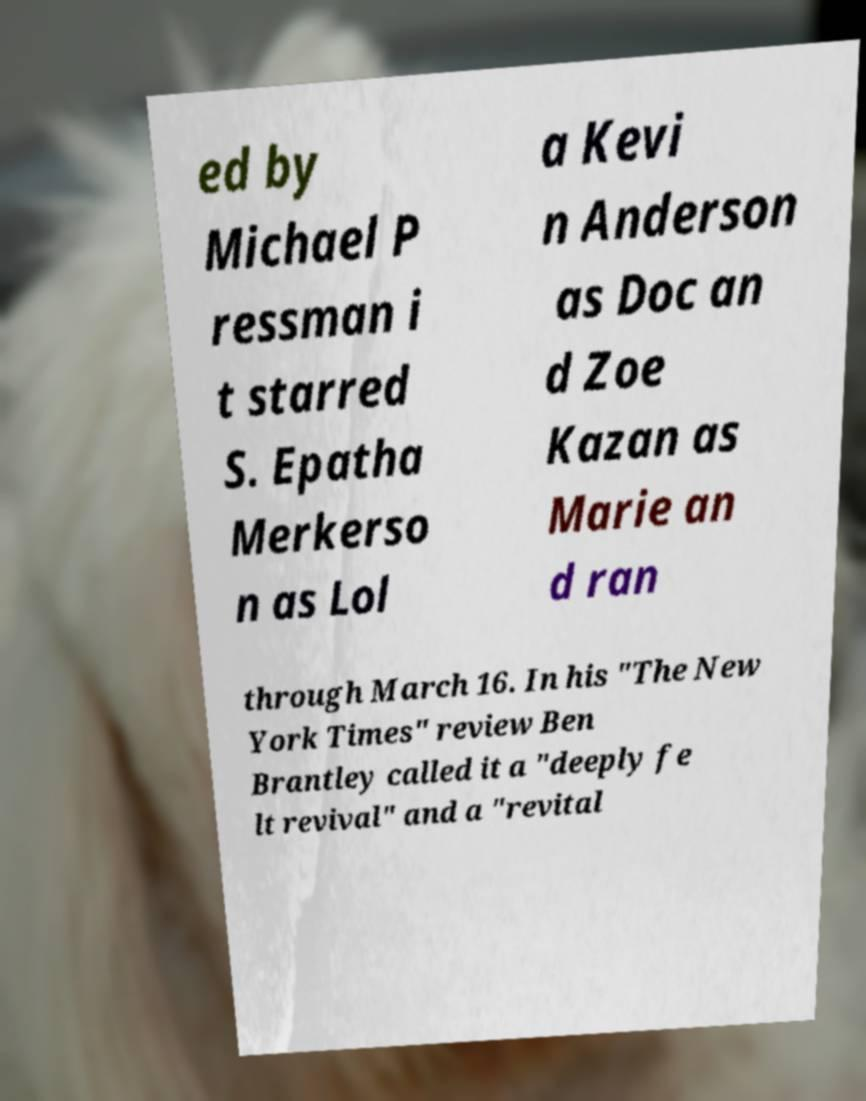Could you assist in decoding the text presented in this image and type it out clearly? ed by Michael P ressman i t starred S. Epatha Merkerso n as Lol a Kevi n Anderson as Doc an d Zoe Kazan as Marie an d ran through March 16. In his "The New York Times" review Ben Brantley called it a "deeply fe lt revival" and a "revital 